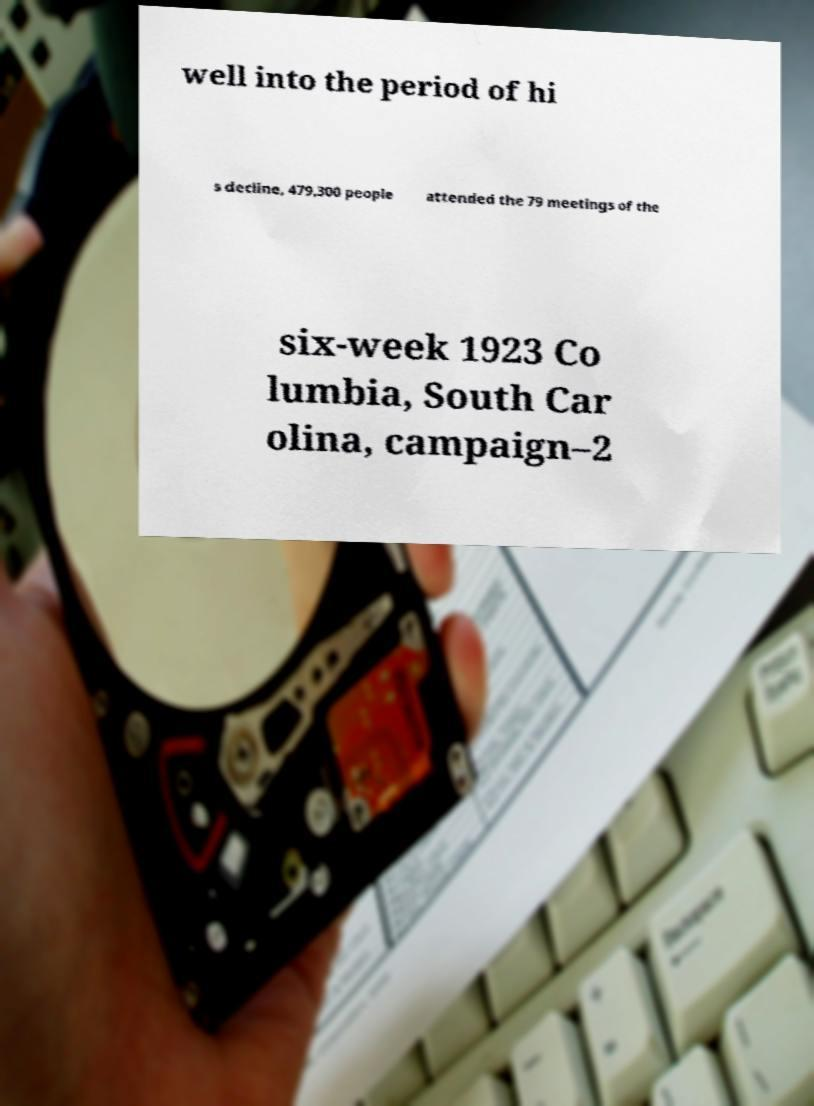Please identify and transcribe the text found in this image. well into the period of hi s decline, 479,300 people attended the 79 meetings of the six-week 1923 Co lumbia, South Car olina, campaign–2 